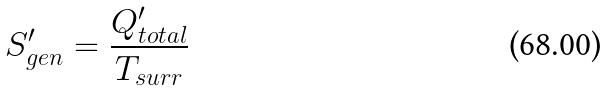<formula> <loc_0><loc_0><loc_500><loc_500>S _ { g e n } ^ { \prime } = \frac { Q _ { t o t a l } ^ { \prime } } { T _ { s u r r } }</formula> 